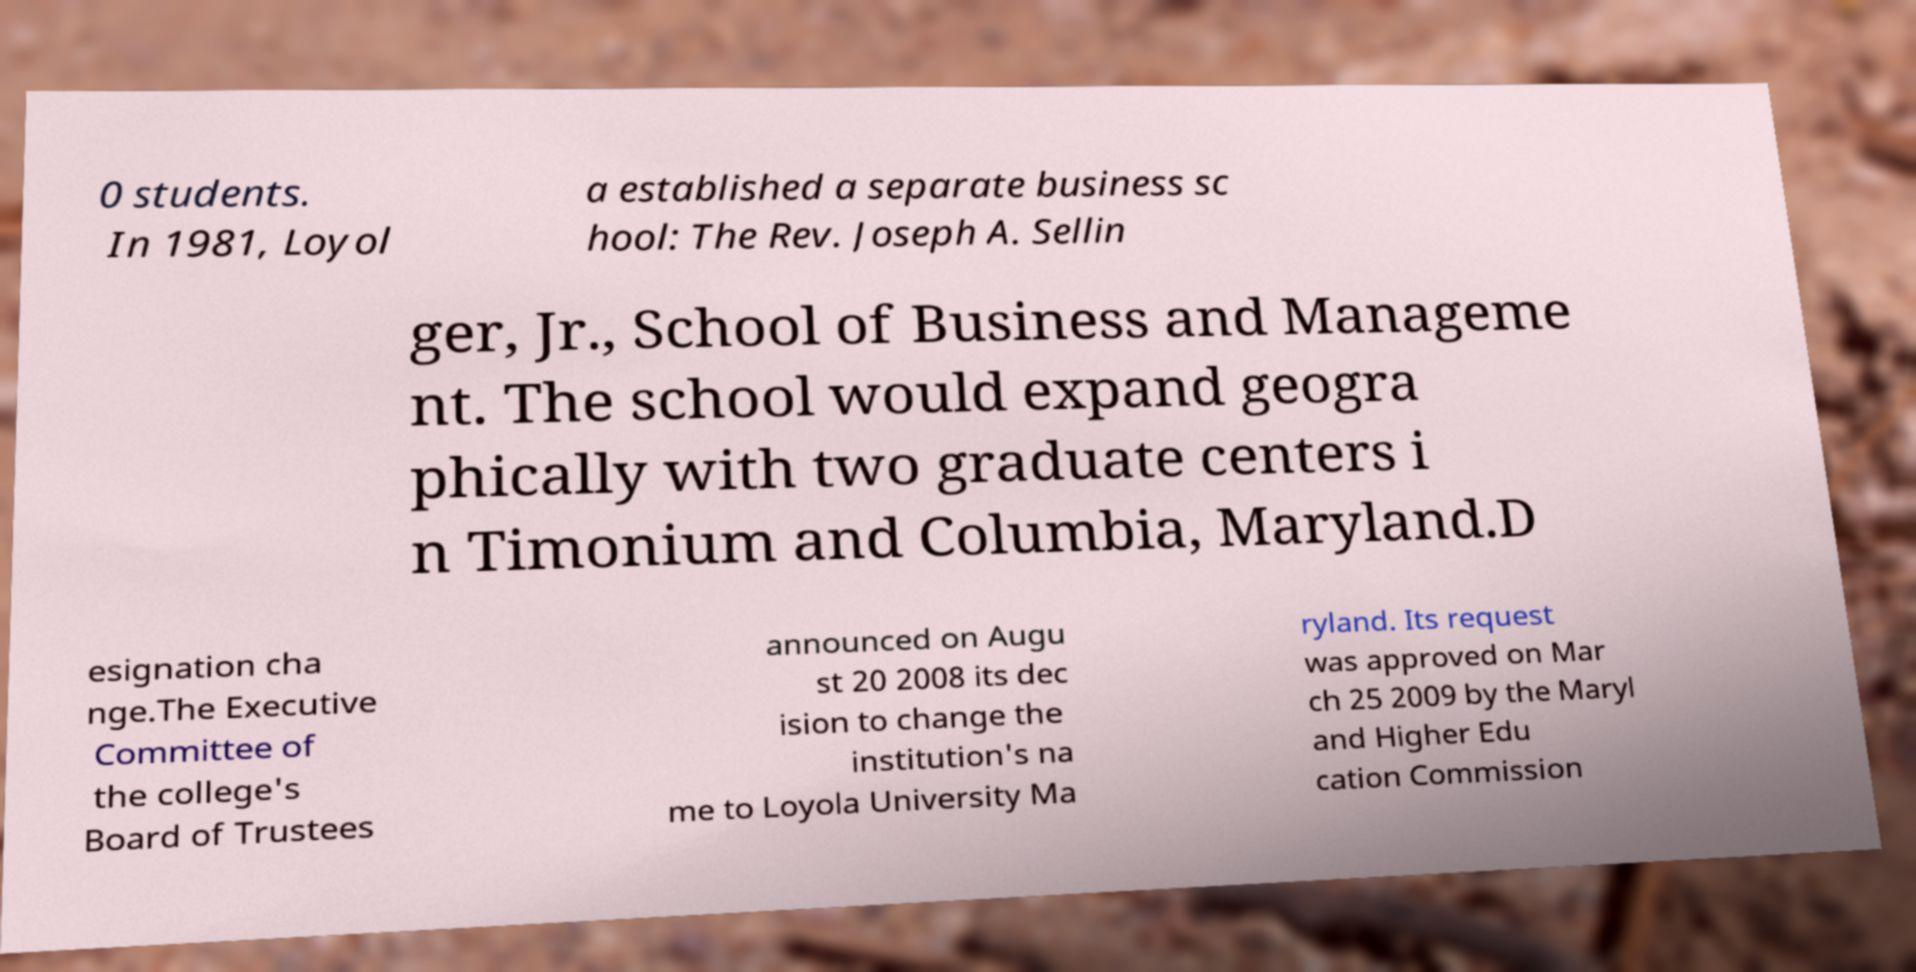Please identify and transcribe the text found in this image. 0 students. In 1981, Loyol a established a separate business sc hool: The Rev. Joseph A. Sellin ger, Jr., School of Business and Manageme nt. The school would expand geogra phically with two graduate centers i n Timonium and Columbia, Maryland.D esignation cha nge.The Executive Committee of the college's Board of Trustees announced on Augu st 20 2008 its dec ision to change the institution's na me to Loyola University Ma ryland. Its request was approved on Mar ch 25 2009 by the Maryl and Higher Edu cation Commission 